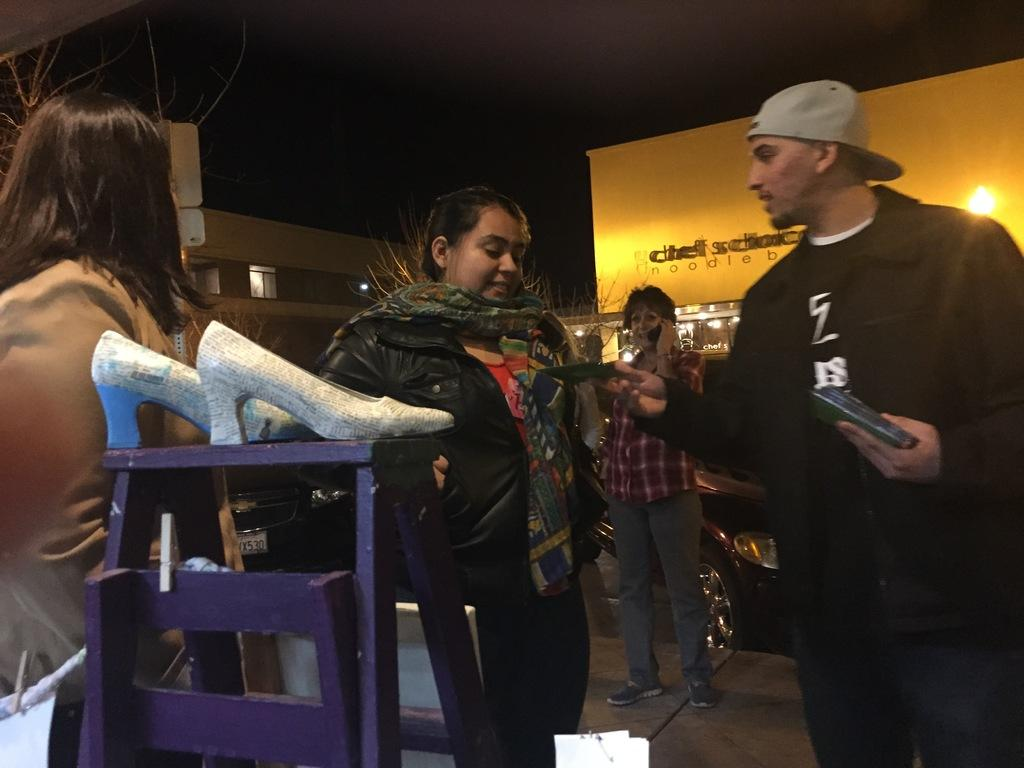What is the main object in the image? There is a table in the image. What is placed on the table? There are slippers on the table. How many people are in the image? There are three women and one man in the image. Where are the people standing? The people are standing on a footpath. What can be seen in the background of the image? There are shops visible in the background of the image. What is the name of the hen in the image? There is no hen present in the image. What type of land can be seen in the image? The image does not show any specific type of land; it only shows a footpath and shops in the background. 